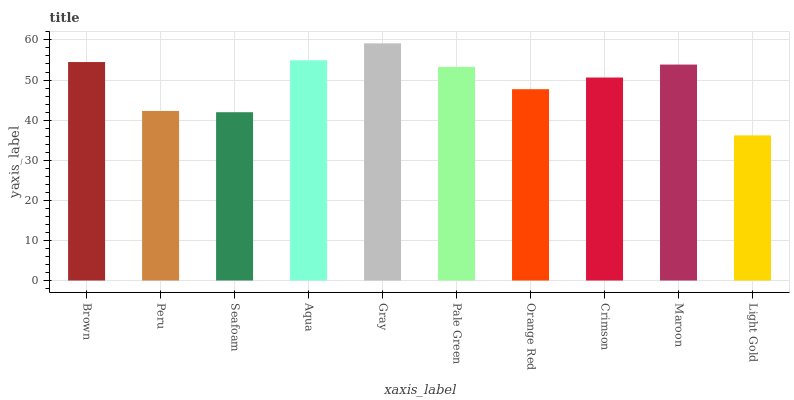Is Peru the minimum?
Answer yes or no. No. Is Peru the maximum?
Answer yes or no. No. Is Brown greater than Peru?
Answer yes or no. Yes. Is Peru less than Brown?
Answer yes or no. Yes. Is Peru greater than Brown?
Answer yes or no. No. Is Brown less than Peru?
Answer yes or no. No. Is Pale Green the high median?
Answer yes or no. Yes. Is Crimson the low median?
Answer yes or no. Yes. Is Peru the high median?
Answer yes or no. No. Is Maroon the low median?
Answer yes or no. No. 